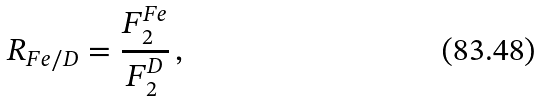Convert formula to latex. <formula><loc_0><loc_0><loc_500><loc_500>R _ { F e / D } = \frac { F _ { 2 } ^ { F e } } { F _ { 2 } ^ { D } } \, ,</formula> 